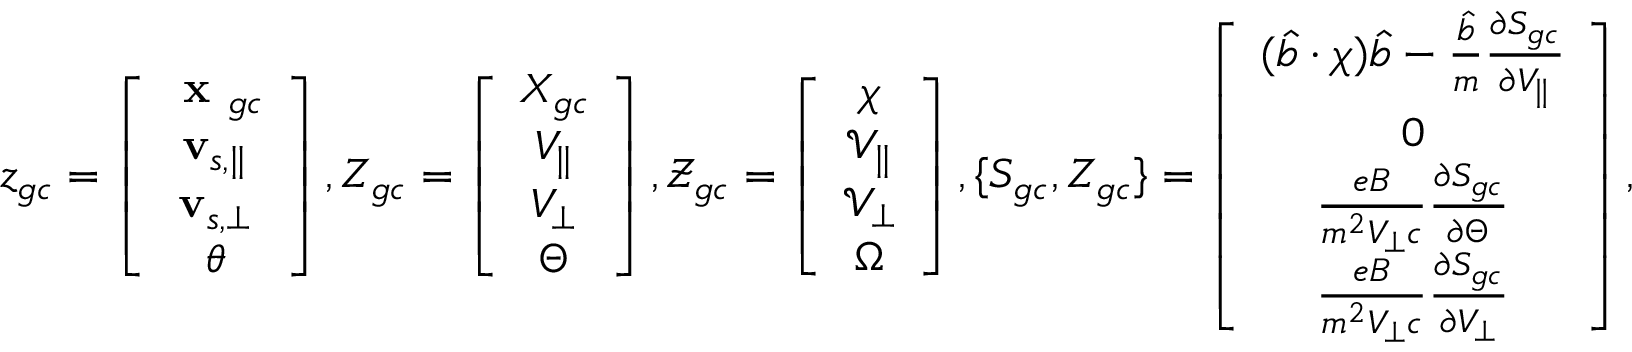<formula> <loc_0><loc_0><loc_500><loc_500>z _ { g c } = \left [ \begin{array} { c } { x _ { g c } } \\ { v _ { s , \| } } \\ { v _ { s , \perp } } \\ { \theta } \end{array} \right ] , Z _ { g c } = \left [ \begin{array} { c } { X _ { g c } } \\ { V _ { \| } } \\ { V _ { \perp } } \\ { \Theta } \end{array} \right ] , \mathcal { Z } _ { g c } = \left [ \begin{array} { c } { \chi } \\ { \mathcal { V } _ { \| } } \\ { \mathcal { V } _ { \perp } } \\ { \Omega } \end{array} \right ] , \{ S _ { g c } , Z _ { g c } \} = \left [ \begin{array} { c } { ( \hat { b } \cdot \chi ) \hat { b } - \frac { \hat { b } } { m } \frac { \partial S _ { g c } } { \partial V _ { \| } } } \\ { 0 } \\ { \frac { e B } { m ^ { 2 } V _ { \perp } c } \frac { \partial S _ { g c } } { \partial \Theta } } \\ { \frac { e B } { m ^ { 2 } V _ { \perp } c } \frac { \partial S _ { g c } } { \partial V _ { \perp } } } \end{array} \right ] ,</formula> 